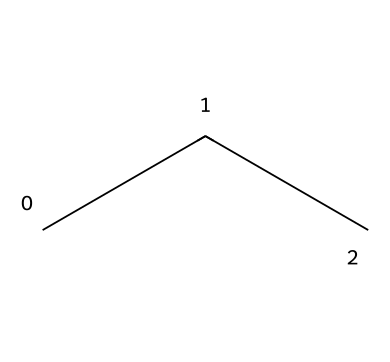How many carbon atoms are in R-290? The SMILES representation "CCC" indicates three connected carbon atoms. Each "C" represents one carbon atom, and the "CC" connections show that they are bonded together, confirming there are three carbons.
Answer: three What is the molecular formula of R-290? The structure "CCC" corresponds to three carbon atoms and eight hydrogen atoms when considering saturation (propane). Therefore, the molecular formula is C3H8, where the number of hydrogen atoms is calculated based on carbon bonding rules.
Answer: C3H8 How many hydrogen atoms are in R-290? In the SMILES notation "CCC," each carbon atom is typically bonded to enough hydrogen atoms to satisfy its four-valence requirement. For three carbon atoms in propane, there are eight hydrogen atoms in total.
Answer: eight What type of chemical bonds are present in R-290? The chemical structure "CCC" shows single bonds between the carbon atoms, which is typical for alkane hydrocarbons. Each pair of connected carbon is linked by a single bond.
Answer: single bonds Is R-290 a natural or synthetic refrigerant? R-290, or propane, is derived from natural sources like gas extraction and is considered an environmentally friendly option compared to many synthetic refrigerants.
Answer: natural What is the primary characteristic of R-290 as a refrigerant? R-290 has low global warming potential (GWP) compared to synthetic refrigerants. This makes it favorable for eco-friendly applications in cooling systems.
Answer: low GWP How does the chain structure of R-290 affect its refrigerant properties? The linear chain of three carbon atoms contributes to its volatility and phase change properties, allowing efficient heat absorption and release during refrigeration cycles.
Answer: affects volatility 